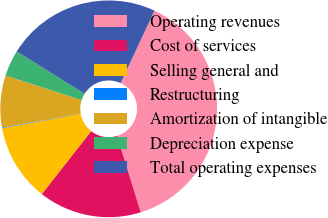Convert chart to OTSL. <chart><loc_0><loc_0><loc_500><loc_500><pie_chart><fcel>Operating revenues<fcel>Cost of services<fcel>Selling general and<fcel>Restructuring<fcel>Amortization of intangible<fcel>Depreciation expense<fcel>Total operating expenses<nl><fcel>38.28%<fcel>15.37%<fcel>11.55%<fcel>0.1%<fcel>7.73%<fcel>3.91%<fcel>23.07%<nl></chart> 